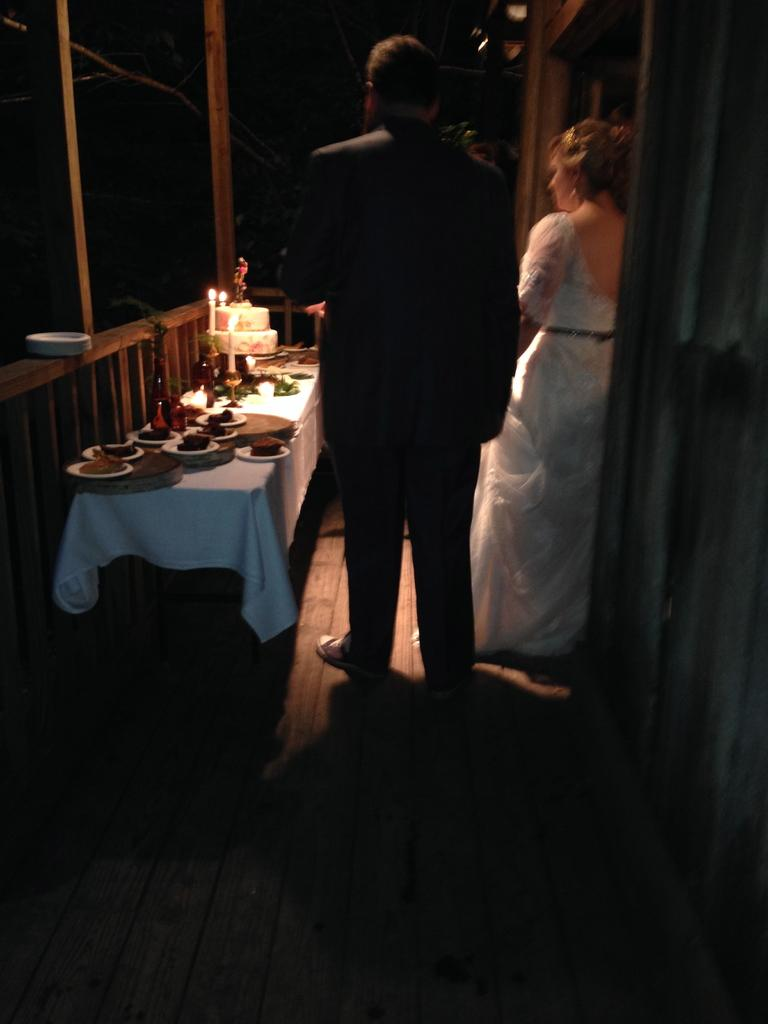How many people are present in the image? There are two people standing in the image. What is the main piece of furniture in the image? There is a table in the image. What is on the table in the image? There is a plate, food, a cake, and a candle on the table. What type of profit can be seen in the image? There is no reference to profit in the image. Can you tell me how many matches are on the table in the image? There is no mention of matches in the image; it only mentions a candle on the table. 